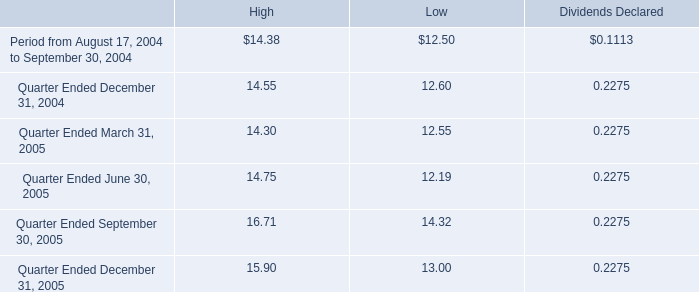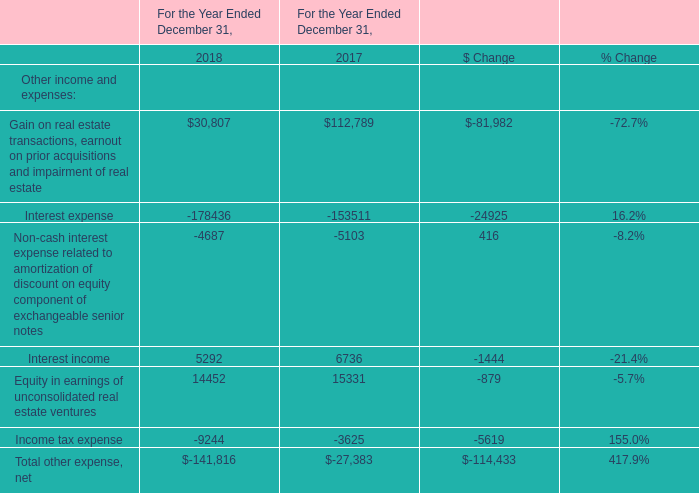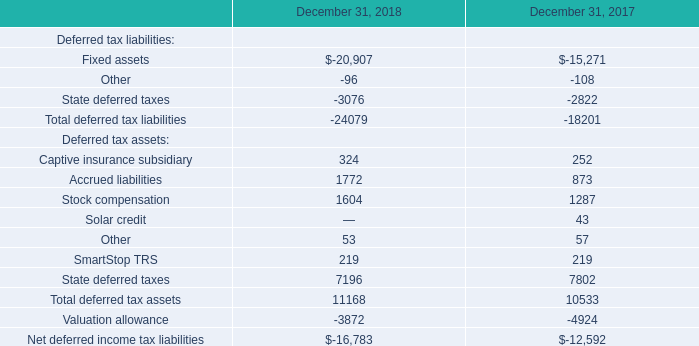In what year is income tax expense greater than 5000? 
Answer: 2018. 